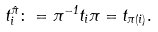Convert formula to latex. <formula><loc_0><loc_0><loc_500><loc_500>t _ { i } ^ { \hat { \pi } } \colon = \pi ^ { - 1 } t _ { i } \pi = t _ { \pi ( i ) } .</formula> 